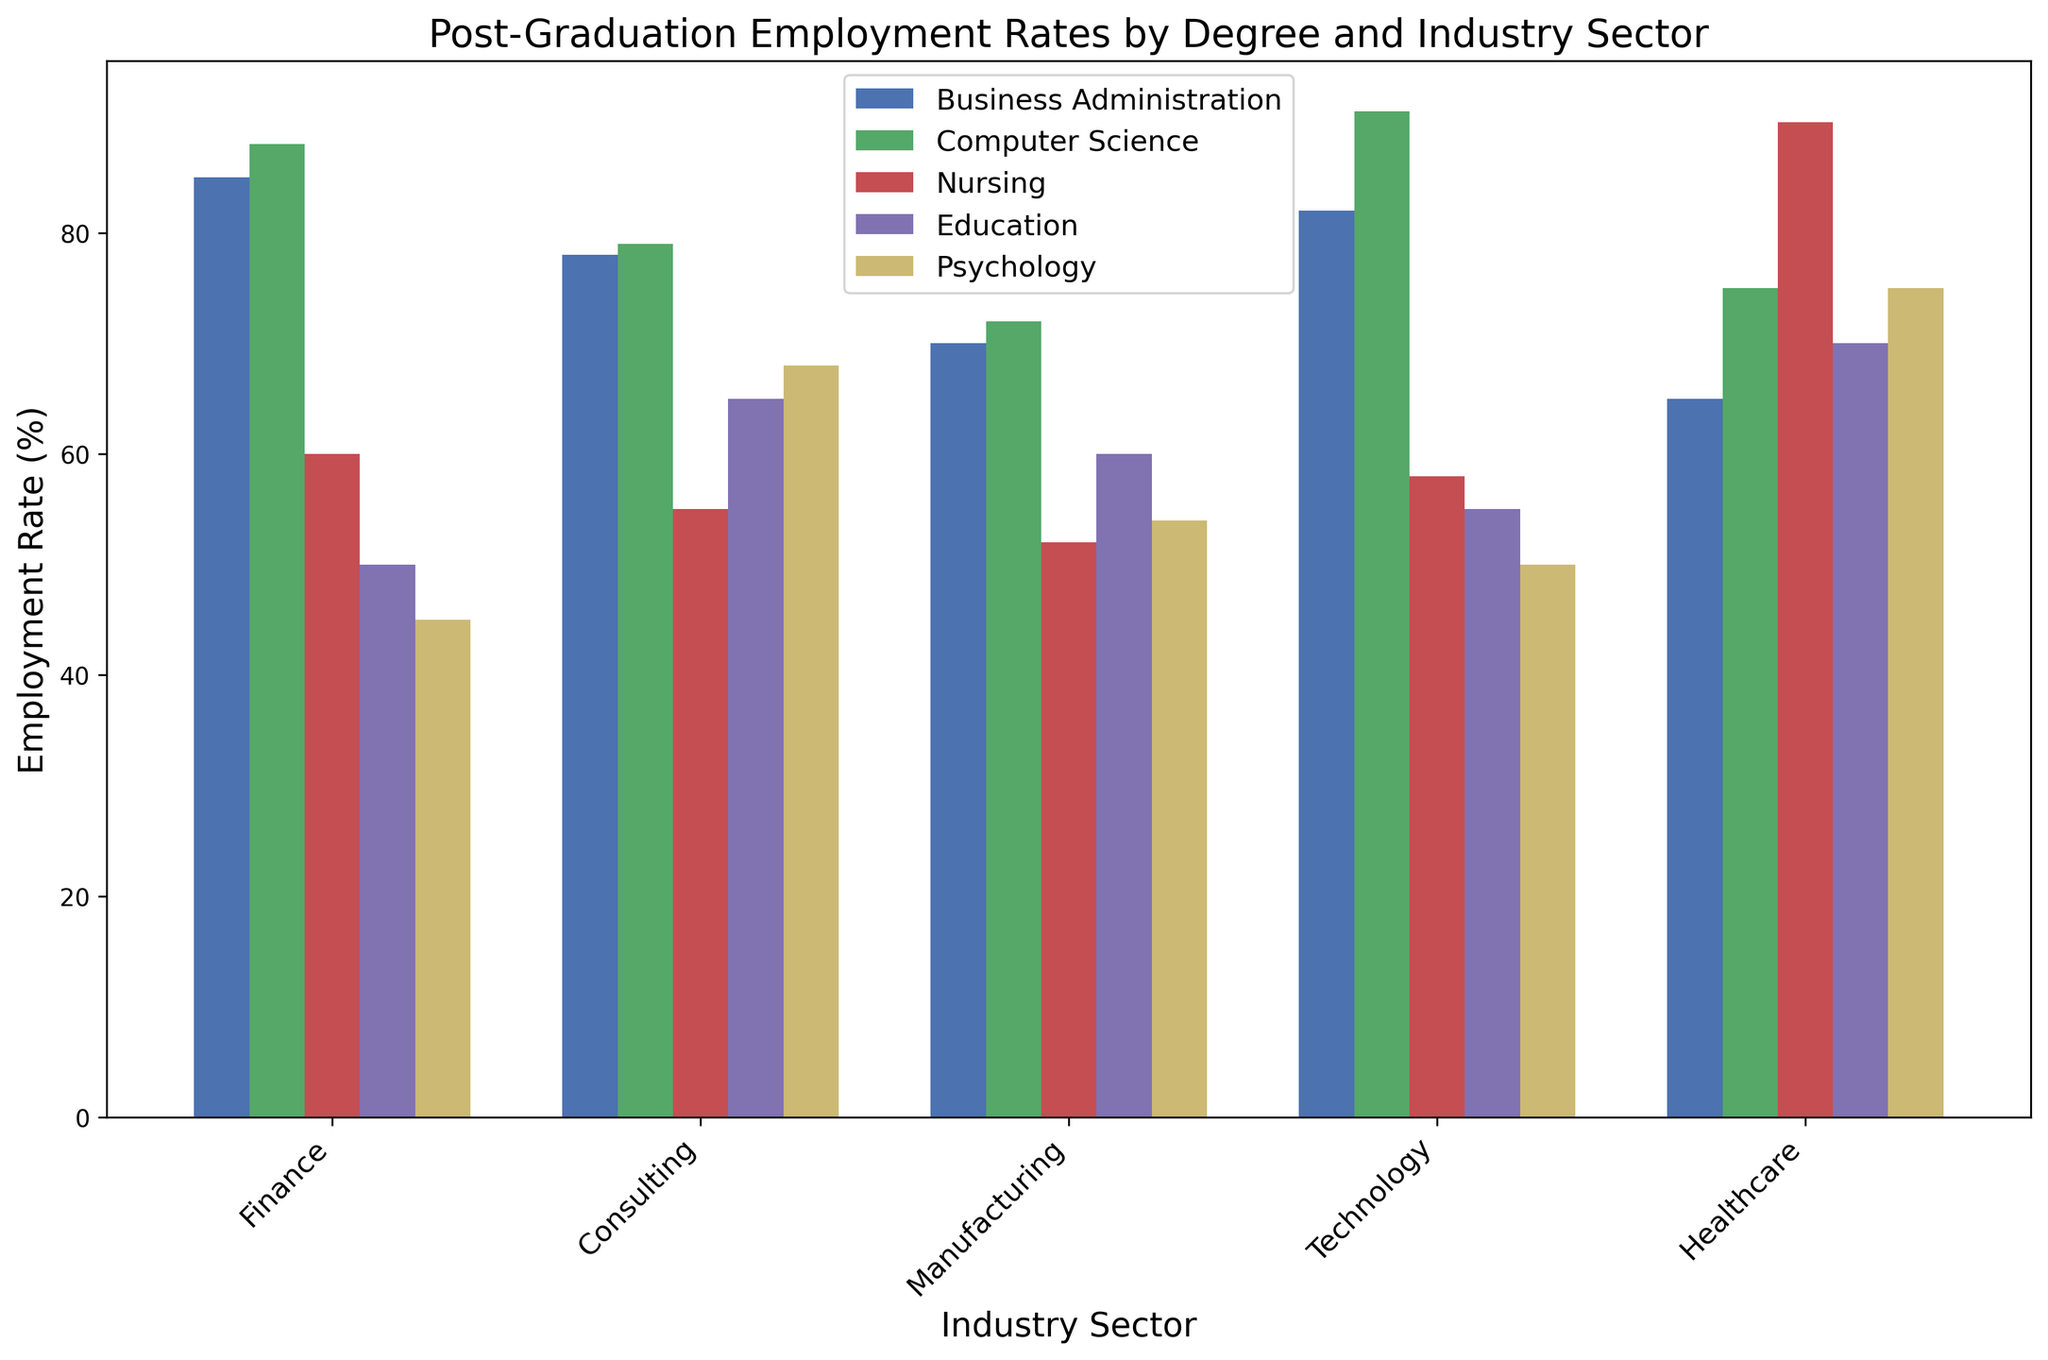Which degree has the highest post-graduation employment rate in the Technology sector? Look at the bars corresponding to the Technology sector and compare their heights to find which one is the tallest. The bar for Computer Science stands out as the highest.
Answer: Computer Science What's the difference in employment rates between Business Administration and Nursing in the Finance sector? Find the bars corresponding to Business Administration and Nursing in the Finance sector. Subtract the Nursing employment rate (60) from the Business Administration rate (85).
Answer: 25 Which sector has the most variation in employment rates across different degrees? Look at the bars for each sector and assess the range of heights. The Finance sector shows the greatest variation, with the highest bar (Computer Science, 88) and the lowest bar (Psychology, 45).
Answer: Finance What is the average employment rate for Computer Science across all sectors? Sum the employment rates for Computer Science across all sectors (88, 79, 72, 91, 75) and divide by the number of sectors (5).
Answer: 81 Which degree has the lowest employment rate in the Consulting sector? Compare the bars corresponding to the Consulting sector and identify the shortest one. The bar for Nursing is the shortest.
Answer: Nursing What is the difference in employment rates between the highest and lowest values in the Healthcare sector? Identify the bars in the Healthcare sector and find the highest (Nursing, 90) and lowest (Business Administration, 65). Subtract the lowest from the highest value.
Answer: 25 How does the employment rate for Psychology in the Healthcare sector compare to that in the Manufacturing sector? Compare the height of the Psychology bars in the Manufacturing (54) and Healthcare (75) sectors.
Answer: Higher in Healthcare Which degree has a higher average employment rate across all sectors, Business Administration or Computer Science? Calculate the average employment rate for Business Administration (85, 78, 70, 82, 65) and Computer Science (88, 79, 72, 91, 75), then compare the two averages.
Answer: Computer Science Between the Education and Psychology degrees, which one has a better rate in the Healthcare sector? Compare the heights of the bars for Education and Psychology in the Healthcare sector. The bar for Psychology is higher.
Answer: Psychology What is the overall employment rate difference between Business Administration in the Technology sector and Nursing in the same sector? Find the employment rates for Business Administration and Nursing in the Technology sector. Subtract Nursing rate (58) from Business Administration rate (82).
Answer: 24 